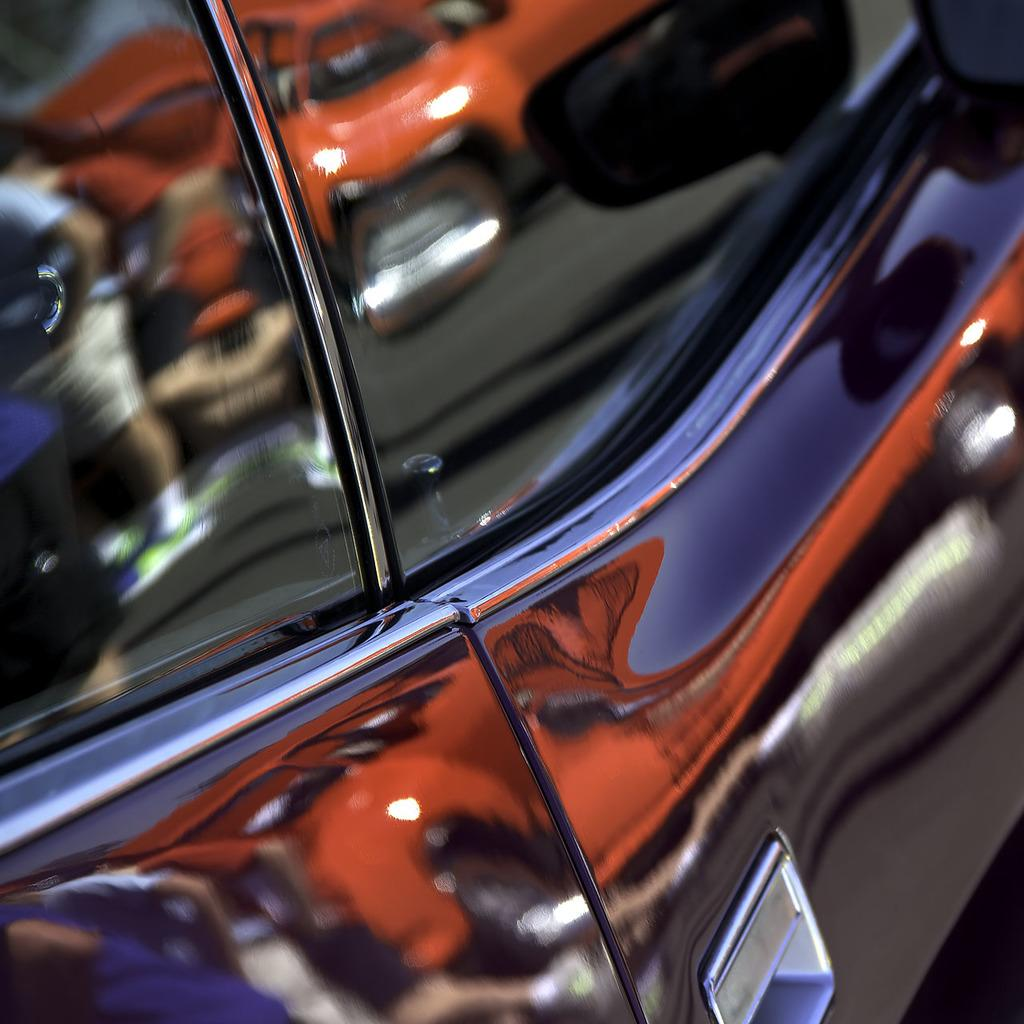What color is the vehicle that is the main subject of the image? The main vehicle in the image is black-colored. Can you describe any other vehicles visible in the image? Yes, there is a reflection of an orange-colored vehicle in the image. What is the purpose of the band in the image? There is no band present in the image. 